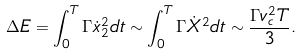<formula> <loc_0><loc_0><loc_500><loc_500>\Delta E = \int _ { 0 } ^ { T } \Gamma \dot { x } _ { 2 } ^ { 2 } d t \sim \int _ { 0 } ^ { T } \Gamma \dot { X } ^ { 2 } d t \sim \frac { \Gamma v _ { c } ^ { 2 } T } { 3 } .</formula> 